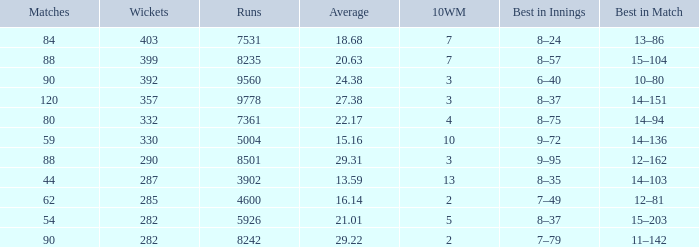What is the aggregate of runs related to 10wm values above 13? None. 